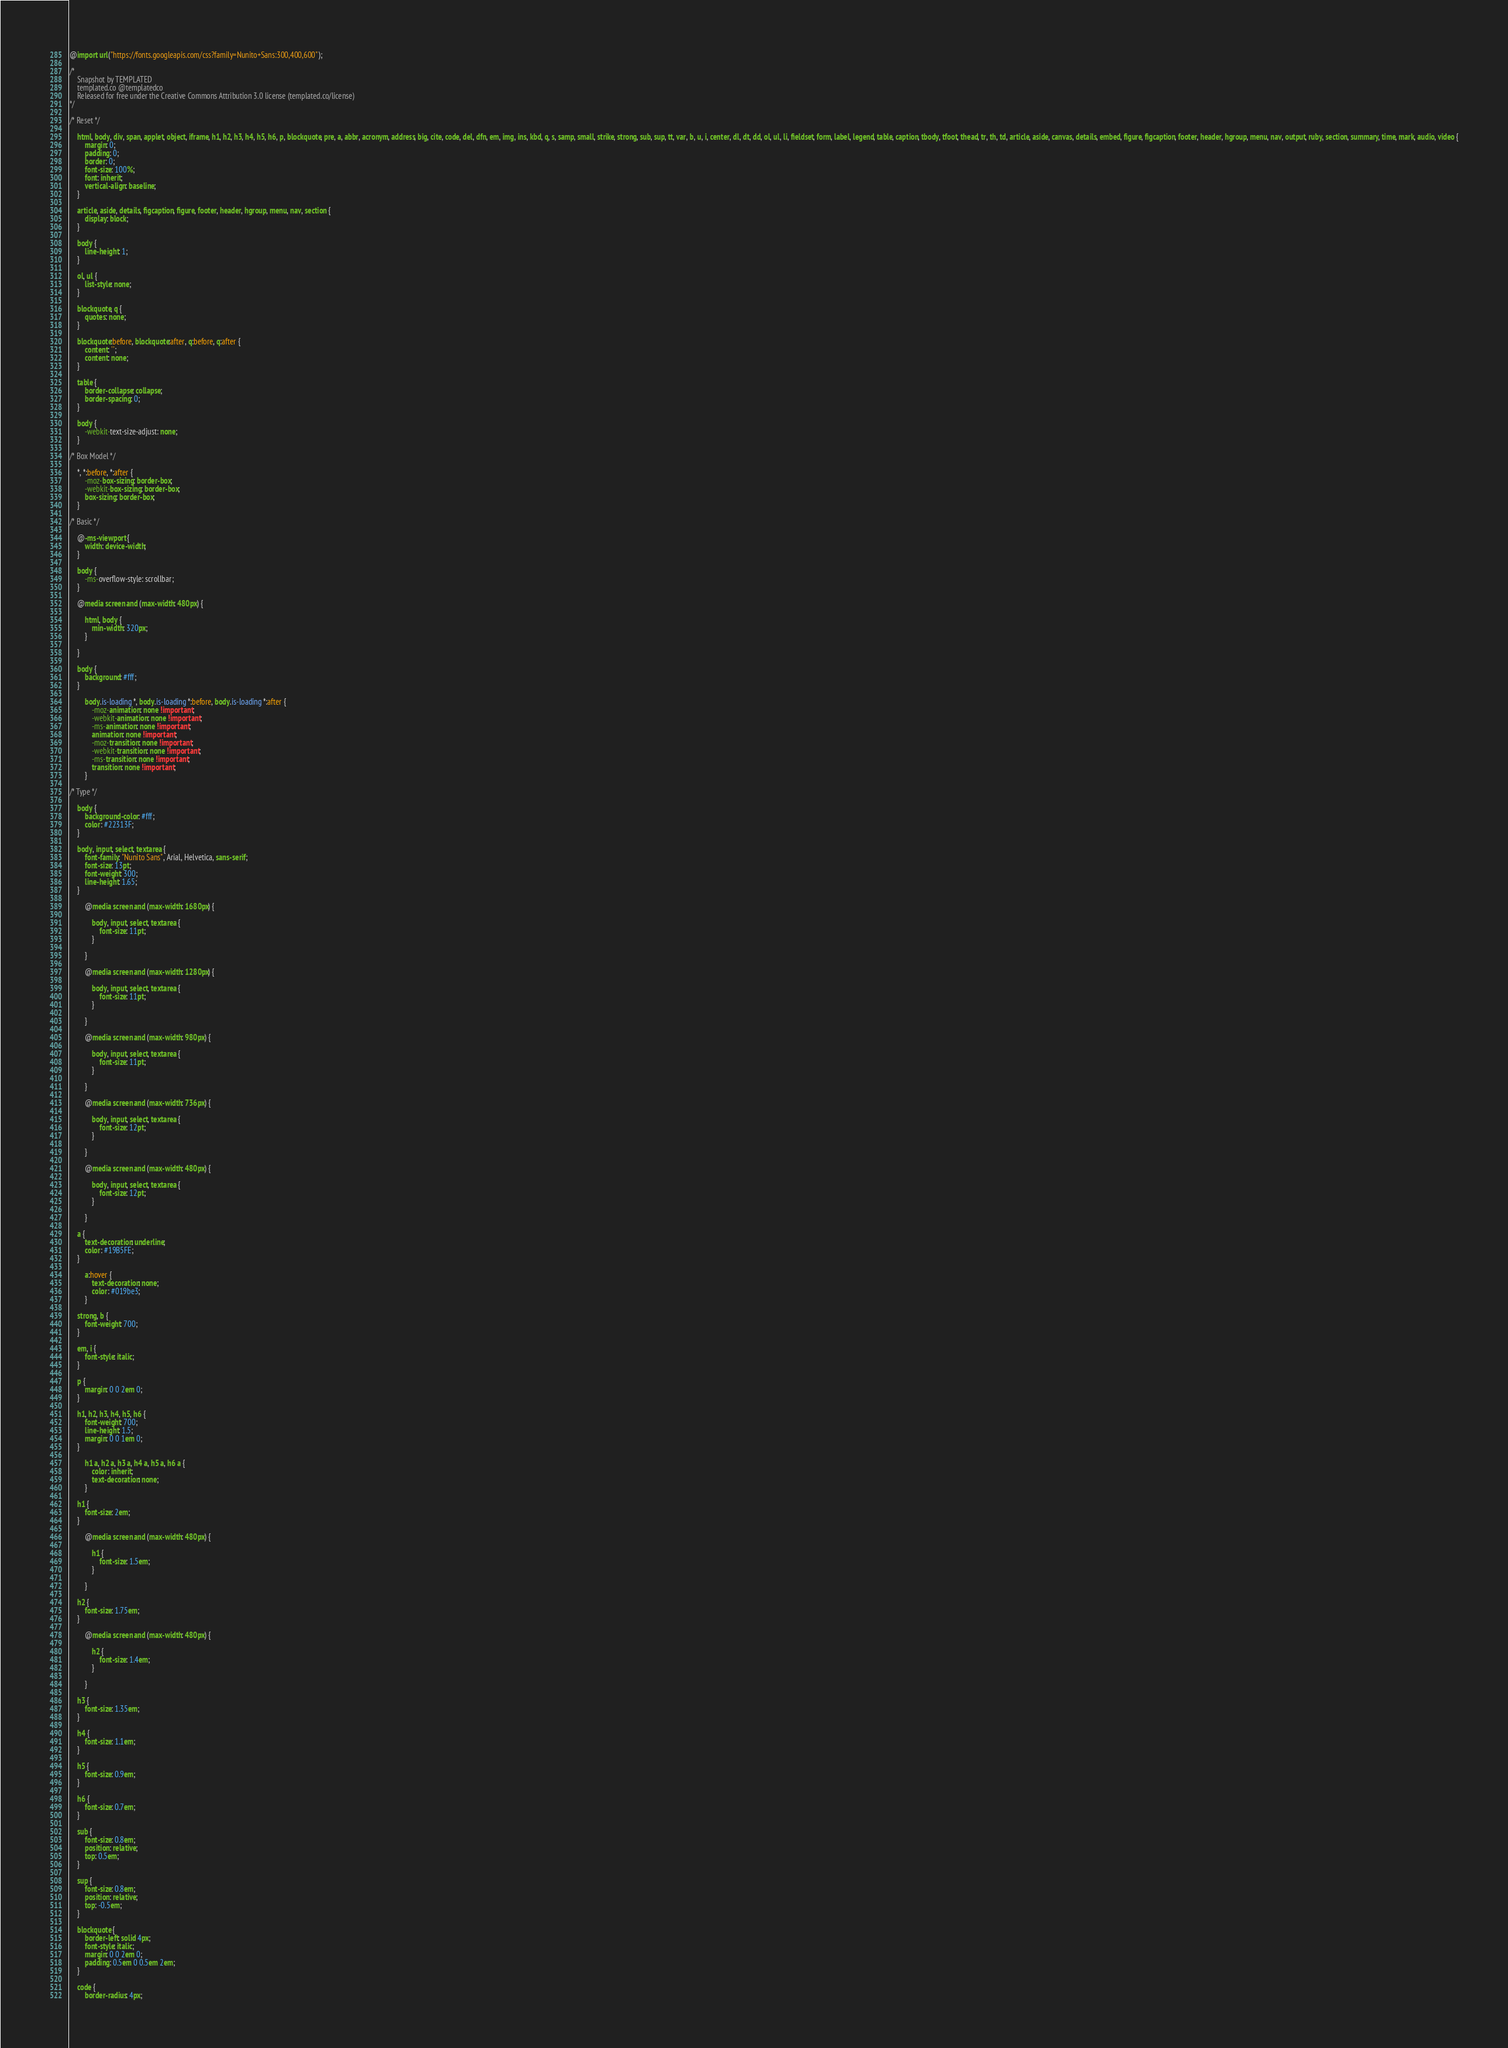Convert code to text. <code><loc_0><loc_0><loc_500><loc_500><_CSS_>
@import url("https://fonts.googleapis.com/css?family=Nunito+Sans:300,400,600");

/*
	Snapshot by TEMPLATED
	templated.co @templatedco
	Released for free under the Creative Commons Attribution 3.0 license (templated.co/license)
*/

/* Reset */

	html, body, div, span, applet, object, iframe, h1, h2, h3, h4, h5, h6, p, blockquote, pre, a, abbr, acronym, address, big, cite, code, del, dfn, em, img, ins, kbd, q, s, samp, small, strike, strong, sub, sup, tt, var, b, u, i, center, dl, dt, dd, ol, ul, li, fieldset, form, label, legend, table, caption, tbody, tfoot, thead, tr, th, td, article, aside, canvas, details, embed, figure, figcaption, footer, header, hgroup, menu, nav, output, ruby, section, summary, time, mark, audio, video {
		margin: 0;
		padding: 0;
		border: 0;
		font-size: 100%;
		font: inherit;
		vertical-align: baseline;
	}

	article, aside, details, figcaption, figure, footer, header, hgroup, menu, nav, section {
		display: block;
	}

	body {
		line-height: 1;
	}

	ol, ul {
		list-style: none;
	}

	blockquote, q {
		quotes: none;
	}

	blockquote:before, blockquote:after, q:before, q:after {
		content: '';
		content: none;
	}

	table {
		border-collapse: collapse;
		border-spacing: 0;
	}

	body {
		-webkit-text-size-adjust: none;
	}

/* Box Model */

	*, *:before, *:after {
		-moz-box-sizing: border-box;
		-webkit-box-sizing: border-box;
		box-sizing: border-box;
	}

/* Basic */

	@-ms-viewport {
		width: device-width;
	}

	body {
		-ms-overflow-style: scrollbar;
	}

	@media screen and (max-width: 480px) {

		html, body {
			min-width: 320px;
		}

	}

	body {
		background: #fff;
	}

		body.is-loading *, body.is-loading *:before, body.is-loading *:after {
			-moz-animation: none !important;
			-webkit-animation: none !important;
			-ms-animation: none !important;
			animation: none !important;
			-moz-transition: none !important;
			-webkit-transition: none !important;
			-ms-transition: none !important;
			transition: none !important;
		}

/* Type */

	body {
		background-color: #fff;
		color: #22313F;
	}

	body, input, select, textarea {
		font-family: "Nunito Sans", Arial, Helvetica, sans-serif;
		font-size: 13pt;
		font-weight: 300;
		line-height: 1.65;
	}

		@media screen and (max-width: 1680px) {

			body, input, select, textarea {
				font-size: 11pt;
			}

		}

		@media screen and (max-width: 1280px) {

			body, input, select, textarea {
				font-size: 11pt;
			}

		}

		@media screen and (max-width: 980px) {

			body, input, select, textarea {
				font-size: 11pt;
			}

		}

		@media screen and (max-width: 736px) {

			body, input, select, textarea {
				font-size: 12pt;
			}

		}

		@media screen and (max-width: 480px) {

			body, input, select, textarea {
				font-size: 12pt;
			}

		}

	a {
		text-decoration: underline;
		color: #19B5FE;
	}

		a:hover {
			text-decoration: none;
			color: #019be3;
		}

	strong, b {
		font-weight: 700;
	}

	em, i {
		font-style: italic;
	}

	p {
		margin: 0 0 2em 0;
	}

	h1, h2, h3, h4, h5, h6 {
		font-weight: 700;
		line-height: 1.5;
		margin: 0 0 1em 0;
	}

		h1 a, h2 a, h3 a, h4 a, h5 a, h6 a {
			color: inherit;
			text-decoration: none;
		}

	h1 {
		font-size: 2em;
	}

		@media screen and (max-width: 480px) {

			h1 {
				font-size: 1.5em;
			}

		}

	h2 {
		font-size: 1.75em;
	}

		@media screen and (max-width: 480px) {

			h2 {
				font-size: 1.4em;
			}

		}

	h3 {
		font-size: 1.35em;
	}

	h4 {
		font-size: 1.1em;
	}

	h5 {
		font-size: 0.9em;
	}

	h6 {
		font-size: 0.7em;
	}

	sub {
		font-size: 0.8em;
		position: relative;
		top: 0.5em;
	}

	sup {
		font-size: 0.8em;
		position: relative;
		top: -0.5em;
	}

	blockquote {
		border-left: solid 4px;
		font-style: italic;
		margin: 0 0 2em 0;
		padding: 0.5em 0 0.5em 2em;
	}

	code {
		border-radius: 4px;</code> 